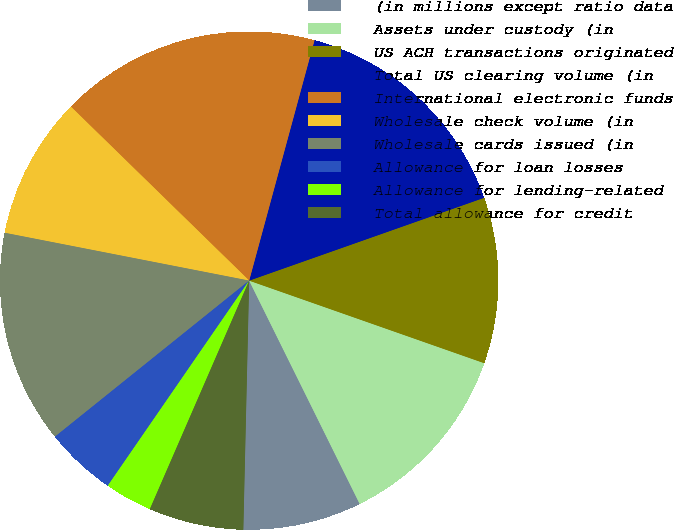<chart> <loc_0><loc_0><loc_500><loc_500><pie_chart><fcel>(in millions except ratio data<fcel>Assets under custody (in<fcel>US ACH transactions originated<fcel>Total US clearing volume (in<fcel>International electronic funds<fcel>Wholesale check volume (in<fcel>Wholesale cards issued (in<fcel>Allowance for loan losses<fcel>Allowance for lending-related<fcel>Total allowance for credit<nl><fcel>7.69%<fcel>12.31%<fcel>10.77%<fcel>15.38%<fcel>16.92%<fcel>9.23%<fcel>13.85%<fcel>4.62%<fcel>3.08%<fcel>6.15%<nl></chart> 